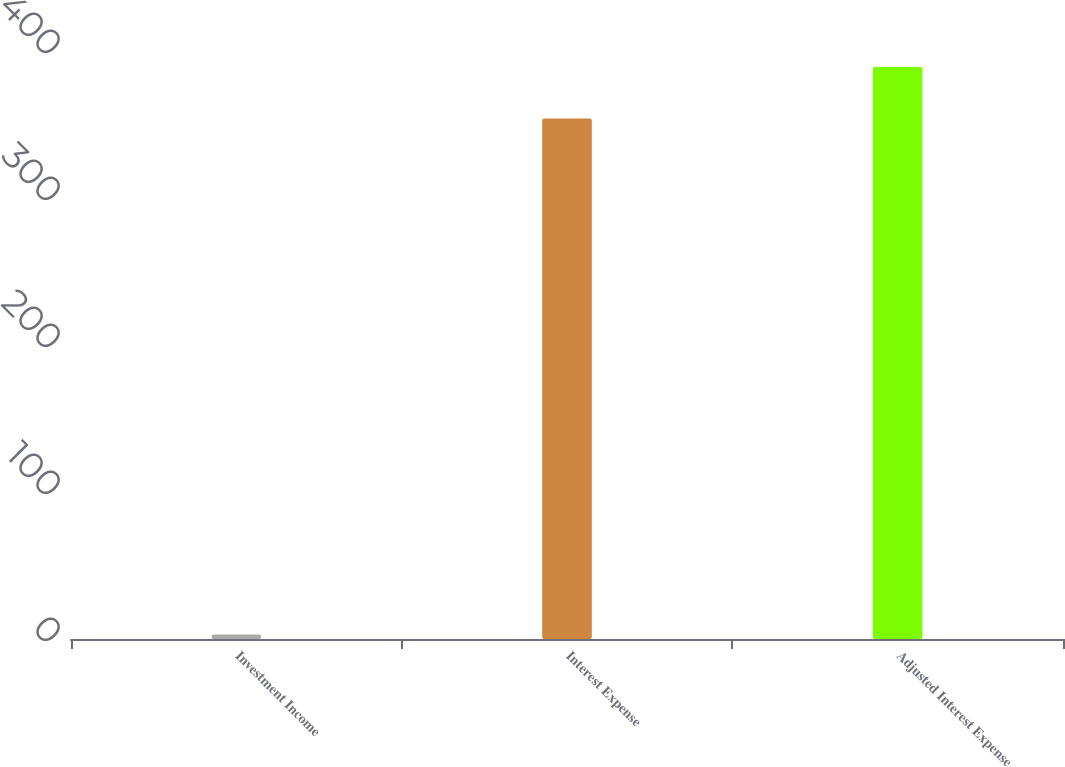Convert chart to OTSL. <chart><loc_0><loc_0><loc_500><loc_500><bar_chart><fcel>Investment Income<fcel>Interest Expense<fcel>Adjusted Interest Expense<nl><fcel>3<fcel>354<fcel>389.1<nl></chart> 